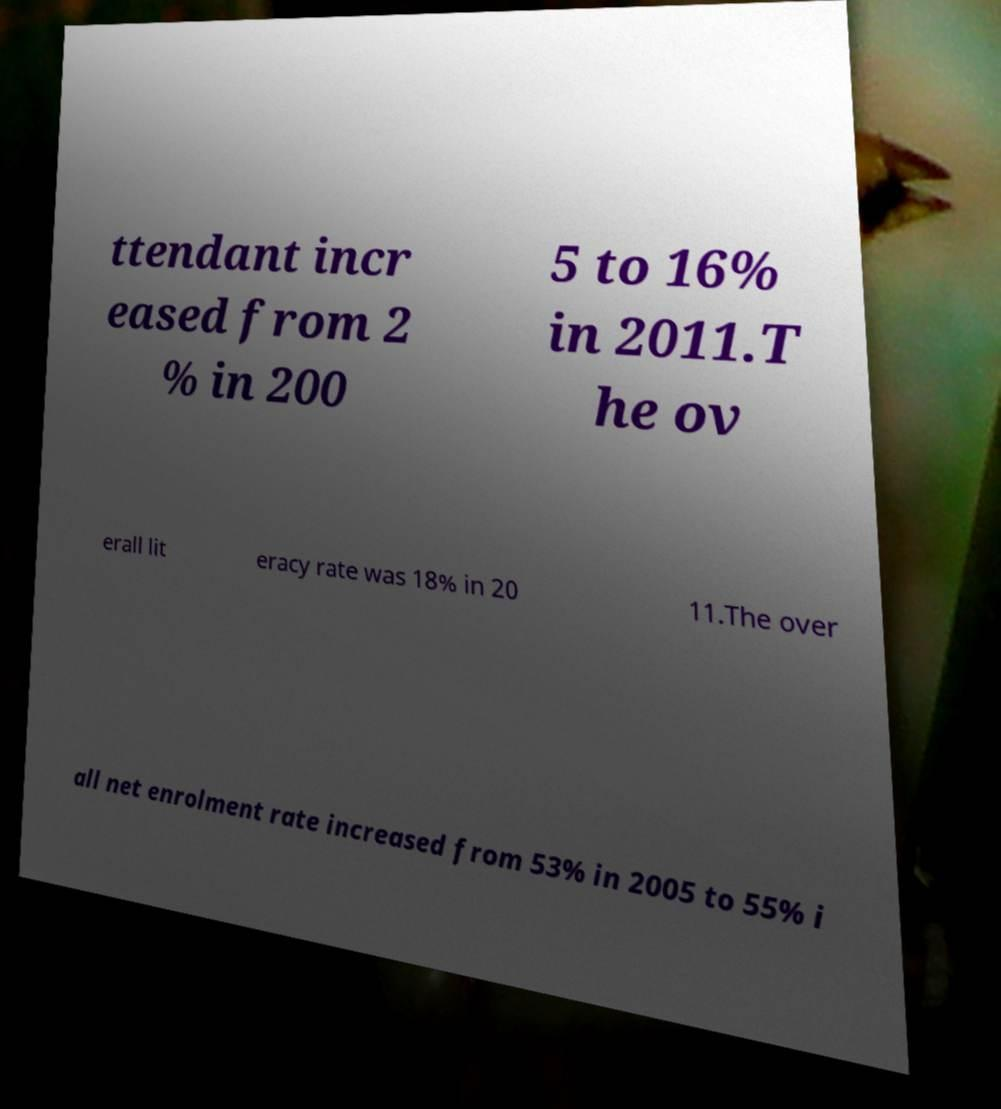There's text embedded in this image that I need extracted. Can you transcribe it verbatim? ttendant incr eased from 2 % in 200 5 to 16% in 2011.T he ov erall lit eracy rate was 18% in 20 11.The over all net enrolment rate increased from 53% in 2005 to 55% i 